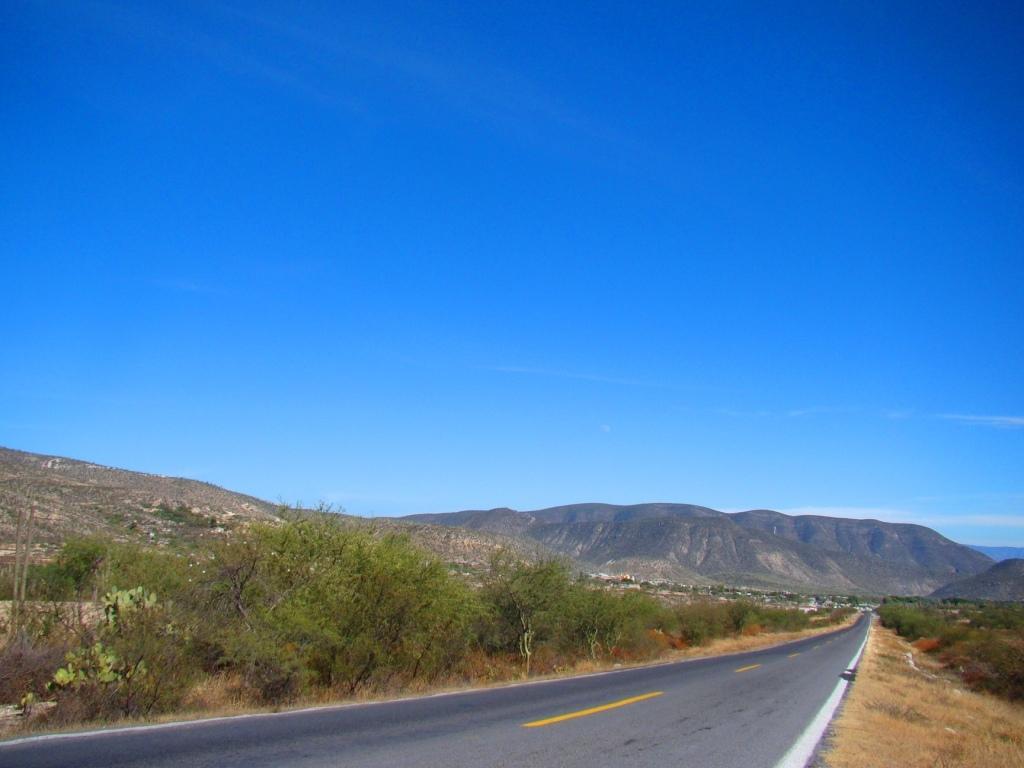Please provide a concise description of this image. In the middle of the image we can see road, beside to the road we can find few trees, in the background we can see few hills and clouds. 